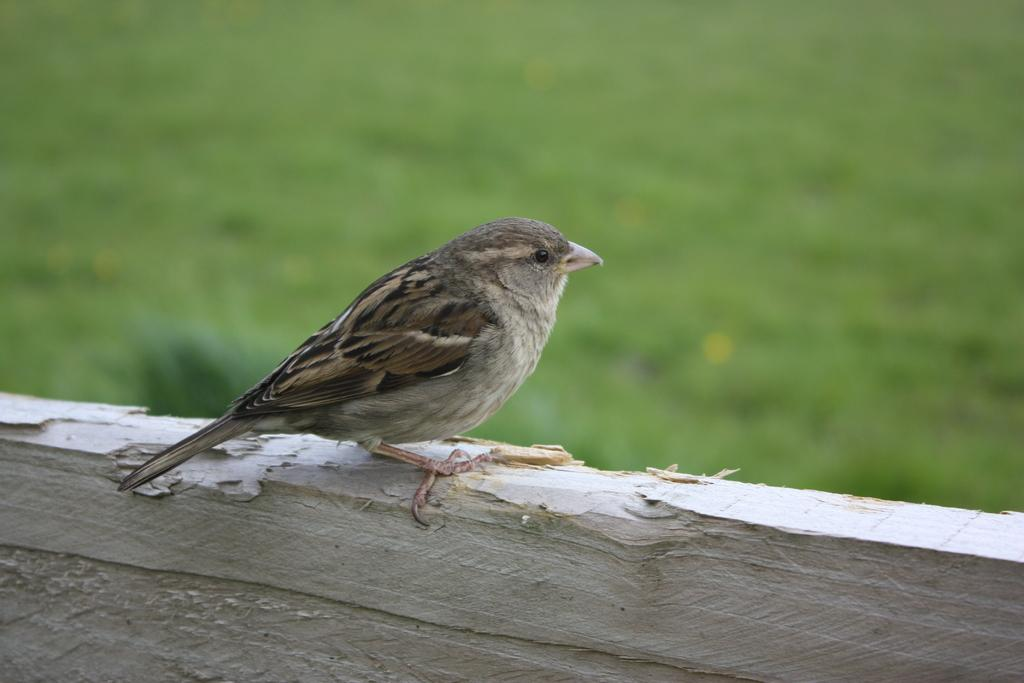What type of bird is in the image? There is a sparrow in the image. Where is the sparrow located? The sparrow is on a wooden wall. What color is the background of the image? The background of the image is green. How is the image blurred? The image is blurred in the background. What type of cup can be seen in the image? There is no cup present in the image; it features a sparrow on a wooden wall with a green background. What hope does the sparrow have in the image? The image does not convey any sense of hope or emotion; it is a simple depiction of a sparrow on a wooden wall. 